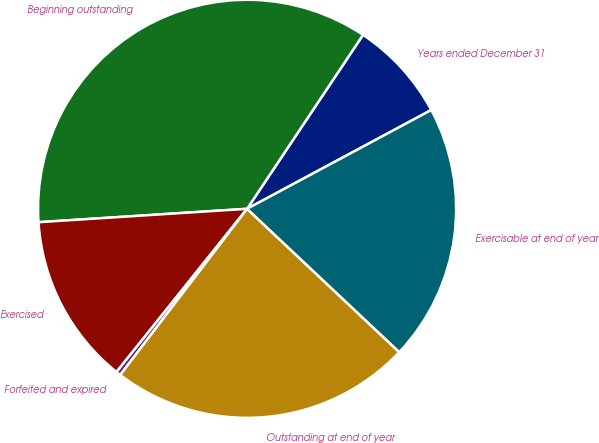Convert chart. <chart><loc_0><loc_0><loc_500><loc_500><pie_chart><fcel>Years ended December 31<fcel>Beginning outstanding<fcel>Exercised<fcel>Forfeited and expired<fcel>Outstanding at end of year<fcel>Exercisable at end of year<nl><fcel>7.81%<fcel>35.38%<fcel>13.24%<fcel>0.36%<fcel>23.36%<fcel>19.86%<nl></chart> 